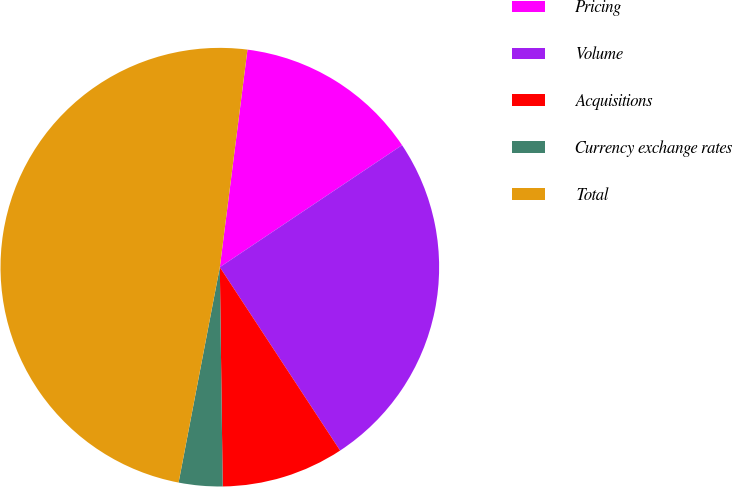<chart> <loc_0><loc_0><loc_500><loc_500><pie_chart><fcel>Pricing<fcel>Volume<fcel>Acquisitions<fcel>Currency exchange rates<fcel>Total<nl><fcel>13.6%<fcel>25.15%<fcel>9.03%<fcel>3.22%<fcel>49.0%<nl></chart> 